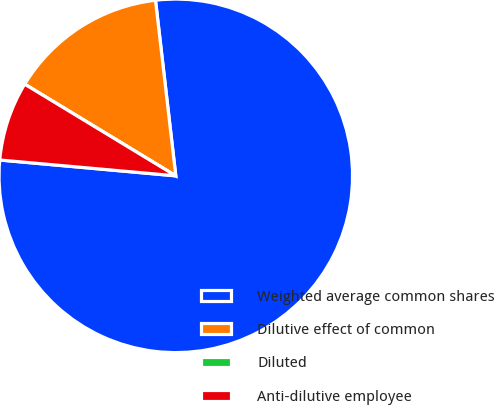Convert chart to OTSL. <chart><loc_0><loc_0><loc_500><loc_500><pie_chart><fcel>Weighted average common shares<fcel>Dilutive effect of common<fcel>Diluted<fcel>Anti-dilutive employee<nl><fcel>78.26%<fcel>14.49%<fcel>0.0%<fcel>7.25%<nl></chart> 